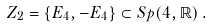Convert formula to latex. <formula><loc_0><loc_0><loc_500><loc_500>Z _ { 2 } = \{ E _ { 4 } , - E _ { 4 } \} \subset S p ( 4 , \mathbb { R } ) \, .</formula> 